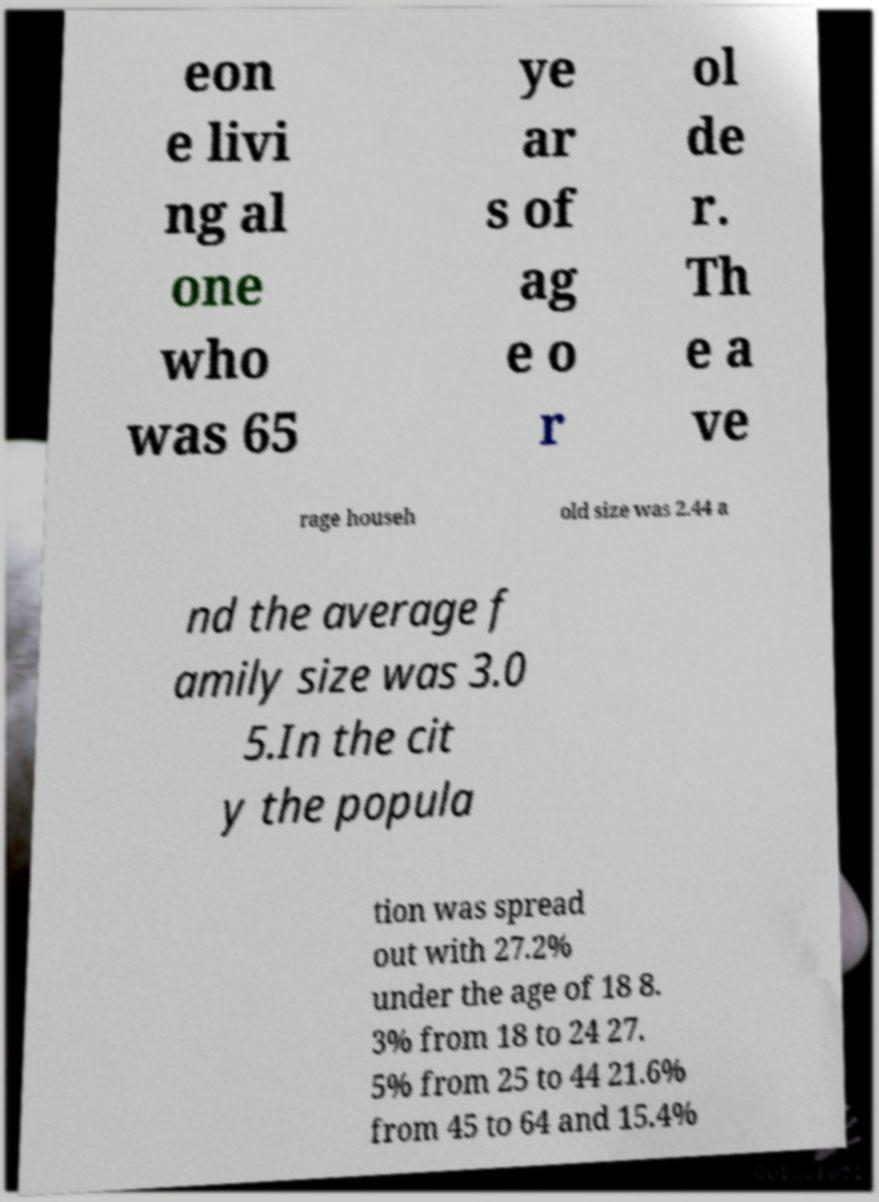Can you accurately transcribe the text from the provided image for me? eon e livi ng al one who was 65 ye ar s of ag e o r ol de r. Th e a ve rage househ old size was 2.44 a nd the average f amily size was 3.0 5.In the cit y the popula tion was spread out with 27.2% under the age of 18 8. 3% from 18 to 24 27. 5% from 25 to 44 21.6% from 45 to 64 and 15.4% 